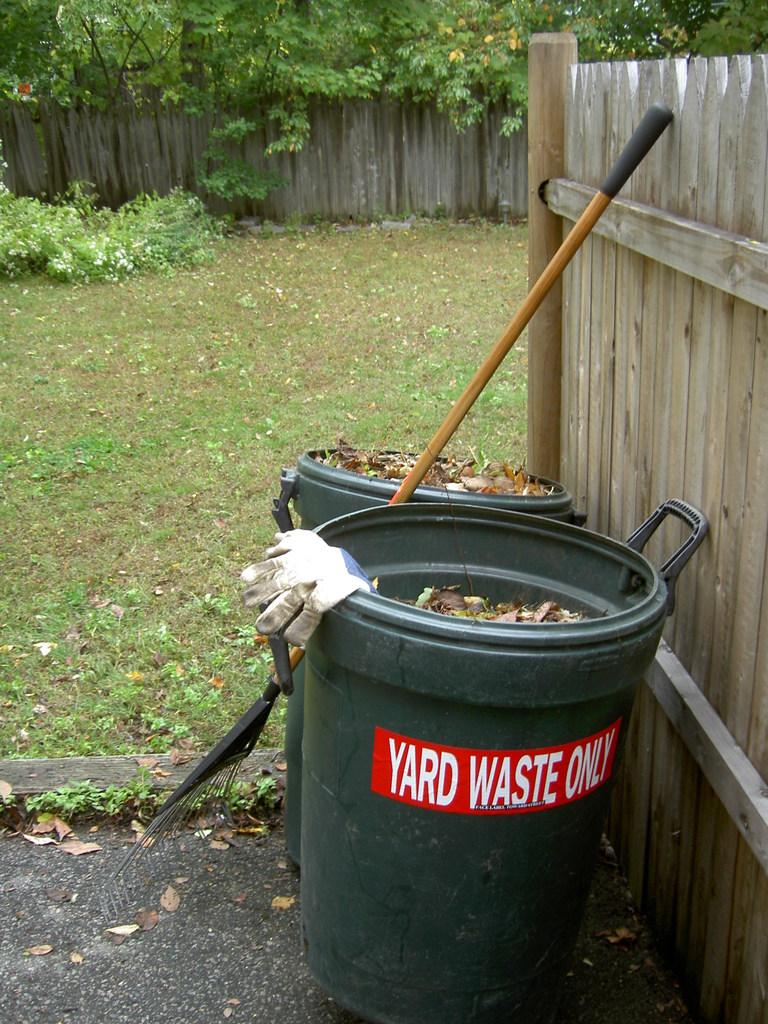Provide a one-sentence caption for the provided image. A backyard with a rake and two trash cans next to a fence, one of which says "yard waste only" on it. 